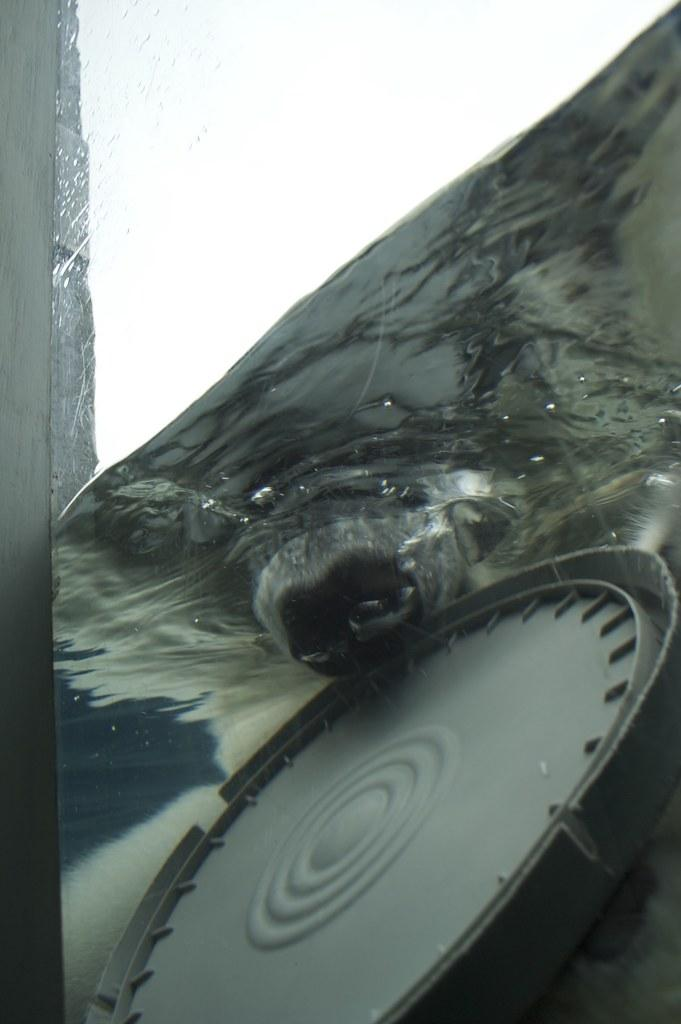What is present in the image that is related to water? There is water visible in the image. What can be seen inside the water? There is an animal's mouth and an object in the water. Can you describe the object on the left side of the image? There is an object on the left side of the image, but its description is not provided in the facts. What is the price of the rabbits in the image? There are no rabbits present in the image, so it is not possible to determine their price. 